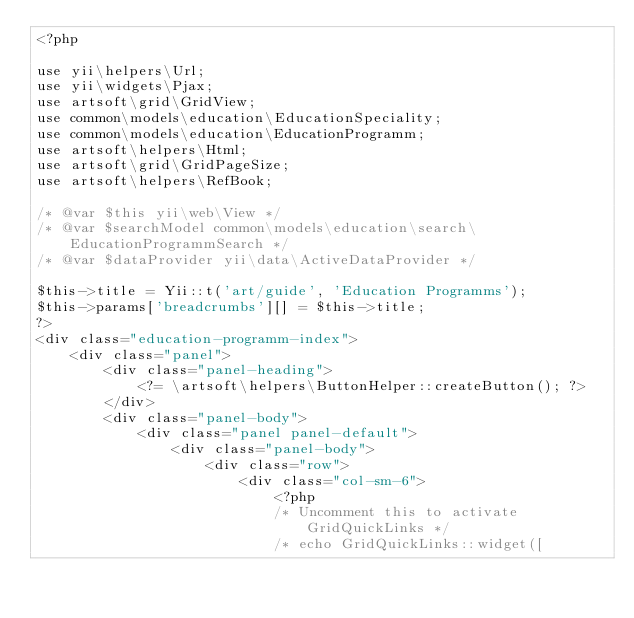Convert code to text. <code><loc_0><loc_0><loc_500><loc_500><_PHP_><?php

use yii\helpers\Url;
use yii\widgets\Pjax;
use artsoft\grid\GridView;
use common\models\education\EducationSpeciality;
use common\models\education\EducationProgramm;
use artsoft\helpers\Html;
use artsoft\grid\GridPageSize;
use artsoft\helpers\RefBook;

/* @var $this yii\web\View */
/* @var $searchModel common\models\education\search\EducationProgrammSearch */
/* @var $dataProvider yii\data\ActiveDataProvider */

$this->title = Yii::t('art/guide', 'Education Programms');
$this->params['breadcrumbs'][] = $this->title;
?>
<div class="education-programm-index">
    <div class="panel">
        <div class="panel-heading">
            <?= \artsoft\helpers\ButtonHelper::createButton(); ?>
        </div>
        <div class="panel-body">
            <div class="panel panel-default">
                <div class="panel-body">
                    <div class="row">
                        <div class="col-sm-6">
                            <?php
                            /* Uncomment this to activate GridQuickLinks */
                            /* echo GridQuickLinks::widget([</code> 